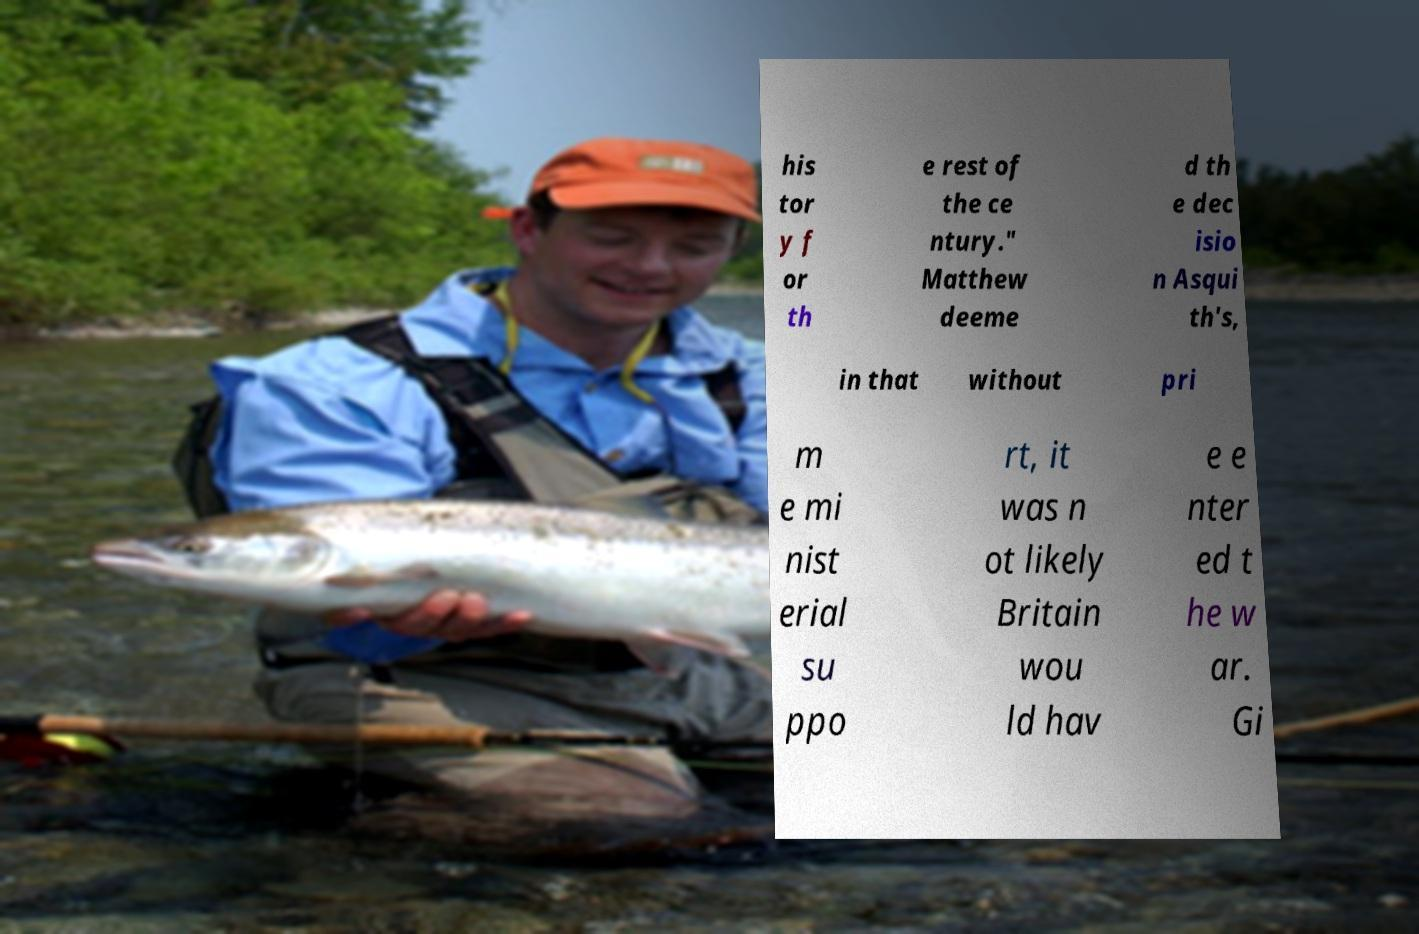Please identify and transcribe the text found in this image. his tor y f or th e rest of the ce ntury." Matthew deeme d th e dec isio n Asqui th's, in that without pri m e mi nist erial su ppo rt, it was n ot likely Britain wou ld hav e e nter ed t he w ar. Gi 